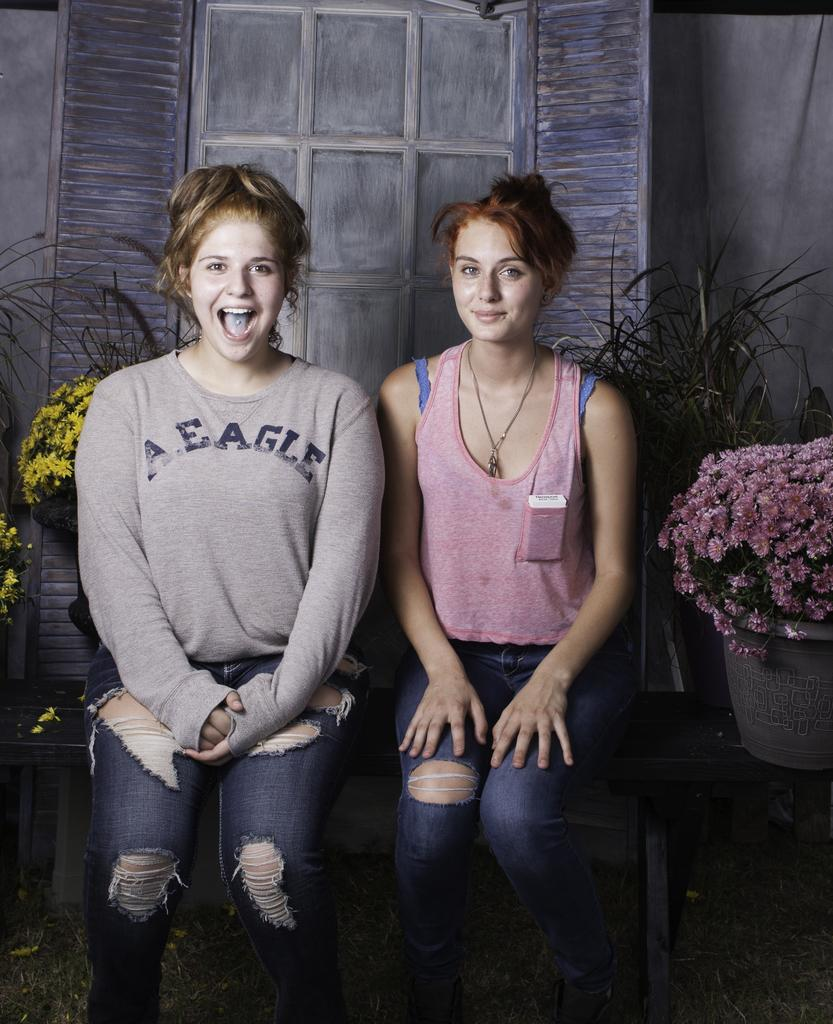How many women are sitting on the bench in the image? There are two women sitting on a bench in the image. What type of vegetation is present in the image? There are plants and flowers in the image. What can be seen in the background of the image? There is a wall and window doors in the background of the image. What type of knot is being tied by the women in the image? There is no knot being tied by the women in the image; they are simply sitting on the bench. 